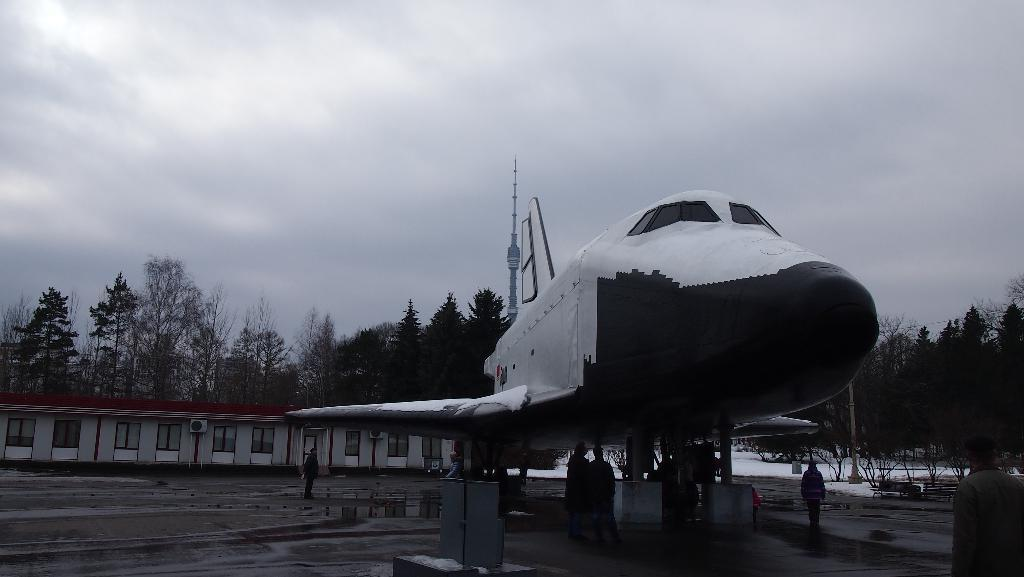What is the main subject of the image? The main subject of the image is an airplane on the ground. Are there any people present in the image? Yes, there are people on the ground in the image. What can be seen in the background of the image? There is a building and trees in the background of the image. What is the condition of the ground in the image? The ground is covered in snow in the image. What type of cake is being served to the people in the image? There is no cake present in the image; it features an airplane on the ground with people nearby. 